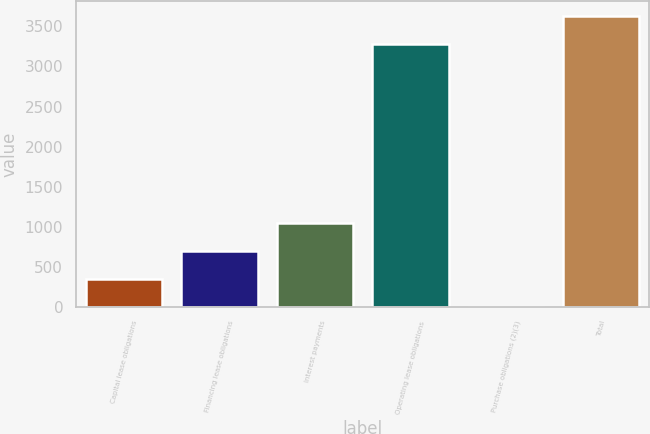<chart> <loc_0><loc_0><loc_500><loc_500><bar_chart><fcel>Capital lease obligations<fcel>Financing lease obligations<fcel>Interest payments<fcel>Operating lease obligations<fcel>Purchase obligations (2)(3)<fcel>Total<nl><fcel>352.8<fcel>702.6<fcel>1052.4<fcel>3282<fcel>3<fcel>3631.8<nl></chart> 